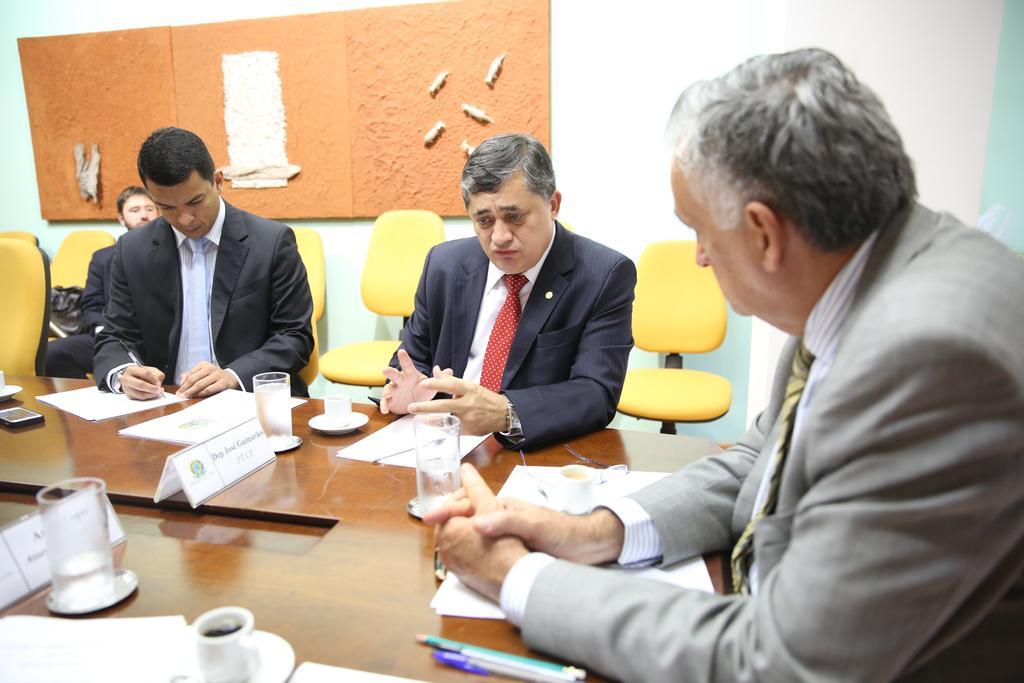Describe this image in one or two sentences. In the picture I can see three persons sitting in chairs and there is a table in front of them which has few papers,cup of coffees,glasses of water and some other objects on it and there is another person sitting in the background and there are some other objects behind him. 